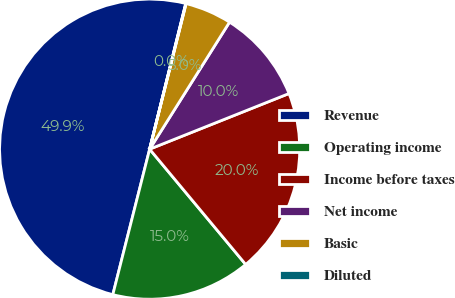Convert chart. <chart><loc_0><loc_0><loc_500><loc_500><pie_chart><fcel>Revenue<fcel>Operating income<fcel>Income before taxes<fcel>Net income<fcel>Basic<fcel>Diluted<nl><fcel>49.92%<fcel>15.0%<fcel>19.99%<fcel>10.02%<fcel>5.03%<fcel>0.04%<nl></chart> 